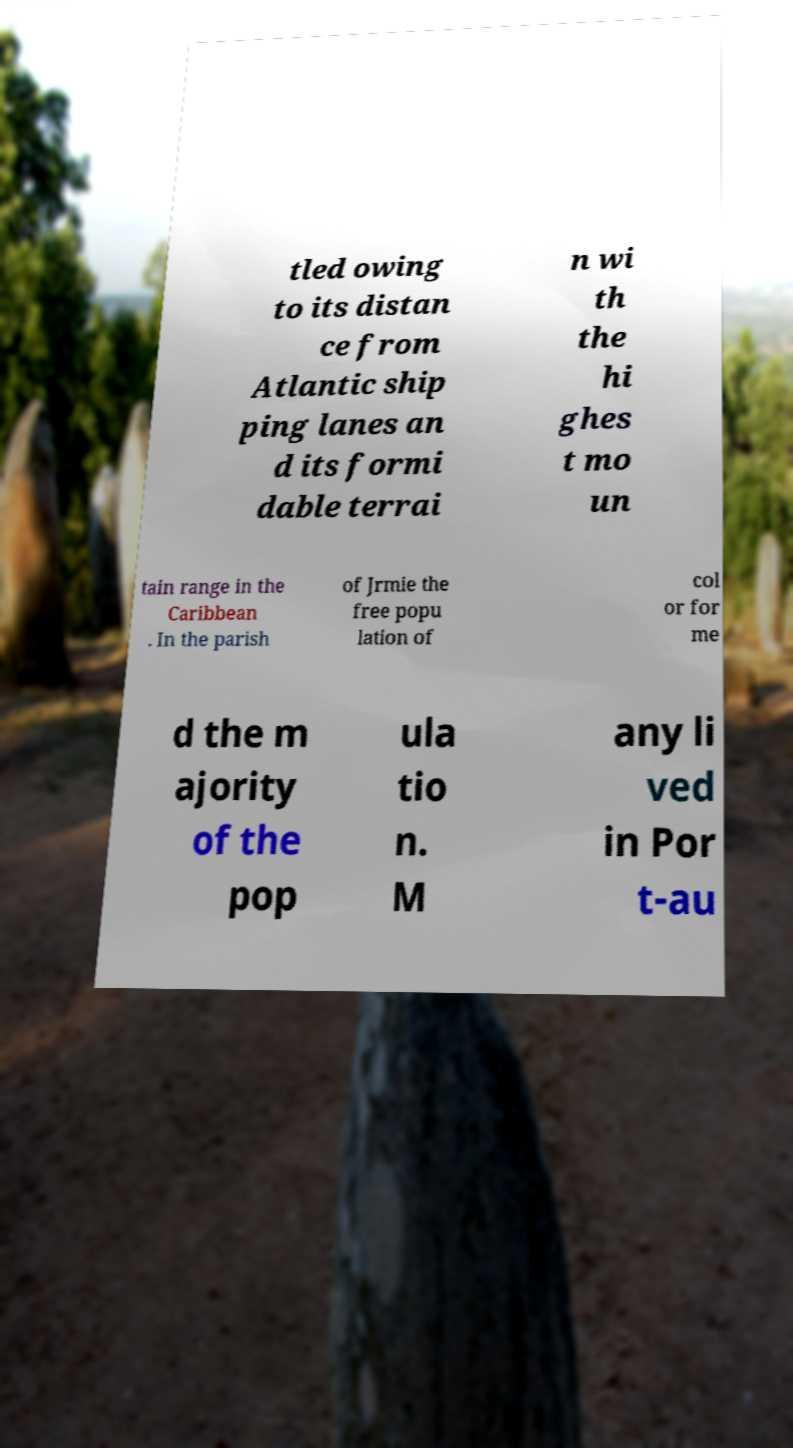What messages or text are displayed in this image? I need them in a readable, typed format. tled owing to its distan ce from Atlantic ship ping lanes an d its formi dable terrai n wi th the hi ghes t mo un tain range in the Caribbean . In the parish of Jrmie the free popu lation of col or for me d the m ajority of the pop ula tio n. M any li ved in Por t-au 